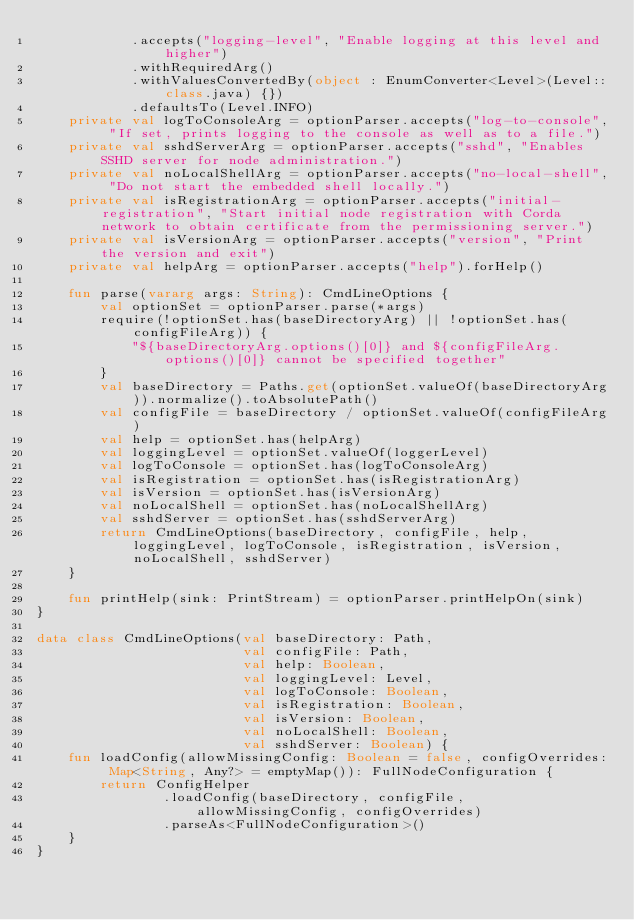Convert code to text. <code><loc_0><loc_0><loc_500><loc_500><_Kotlin_>            .accepts("logging-level", "Enable logging at this level and higher")
            .withRequiredArg()
            .withValuesConvertedBy(object : EnumConverter<Level>(Level::class.java) {})
            .defaultsTo(Level.INFO)
    private val logToConsoleArg = optionParser.accepts("log-to-console", "If set, prints logging to the console as well as to a file.")
    private val sshdServerArg = optionParser.accepts("sshd", "Enables SSHD server for node administration.")
    private val noLocalShellArg = optionParser.accepts("no-local-shell", "Do not start the embedded shell locally.")
    private val isRegistrationArg = optionParser.accepts("initial-registration", "Start initial node registration with Corda network to obtain certificate from the permissioning server.")
    private val isVersionArg = optionParser.accepts("version", "Print the version and exit")
    private val helpArg = optionParser.accepts("help").forHelp()

    fun parse(vararg args: String): CmdLineOptions {
        val optionSet = optionParser.parse(*args)
        require(!optionSet.has(baseDirectoryArg) || !optionSet.has(configFileArg)) {
            "${baseDirectoryArg.options()[0]} and ${configFileArg.options()[0]} cannot be specified together"
        }
        val baseDirectory = Paths.get(optionSet.valueOf(baseDirectoryArg)).normalize().toAbsolutePath()
        val configFile = baseDirectory / optionSet.valueOf(configFileArg)
        val help = optionSet.has(helpArg)
        val loggingLevel = optionSet.valueOf(loggerLevel)
        val logToConsole = optionSet.has(logToConsoleArg)
        val isRegistration = optionSet.has(isRegistrationArg)
        val isVersion = optionSet.has(isVersionArg)
        val noLocalShell = optionSet.has(noLocalShellArg)
        val sshdServer = optionSet.has(sshdServerArg)
        return CmdLineOptions(baseDirectory, configFile, help, loggingLevel, logToConsole, isRegistration, isVersion, noLocalShell, sshdServer)
    }

    fun printHelp(sink: PrintStream) = optionParser.printHelpOn(sink)
}

data class CmdLineOptions(val baseDirectory: Path,
                          val configFile: Path,
                          val help: Boolean,
                          val loggingLevel: Level,
                          val logToConsole: Boolean,
                          val isRegistration: Boolean,
                          val isVersion: Boolean,
                          val noLocalShell: Boolean,
                          val sshdServer: Boolean) {
    fun loadConfig(allowMissingConfig: Boolean = false, configOverrides: Map<String, Any?> = emptyMap()): FullNodeConfiguration {
        return ConfigHelper
                .loadConfig(baseDirectory, configFile, allowMissingConfig, configOverrides)
                .parseAs<FullNodeConfiguration>()
    }
}
</code> 